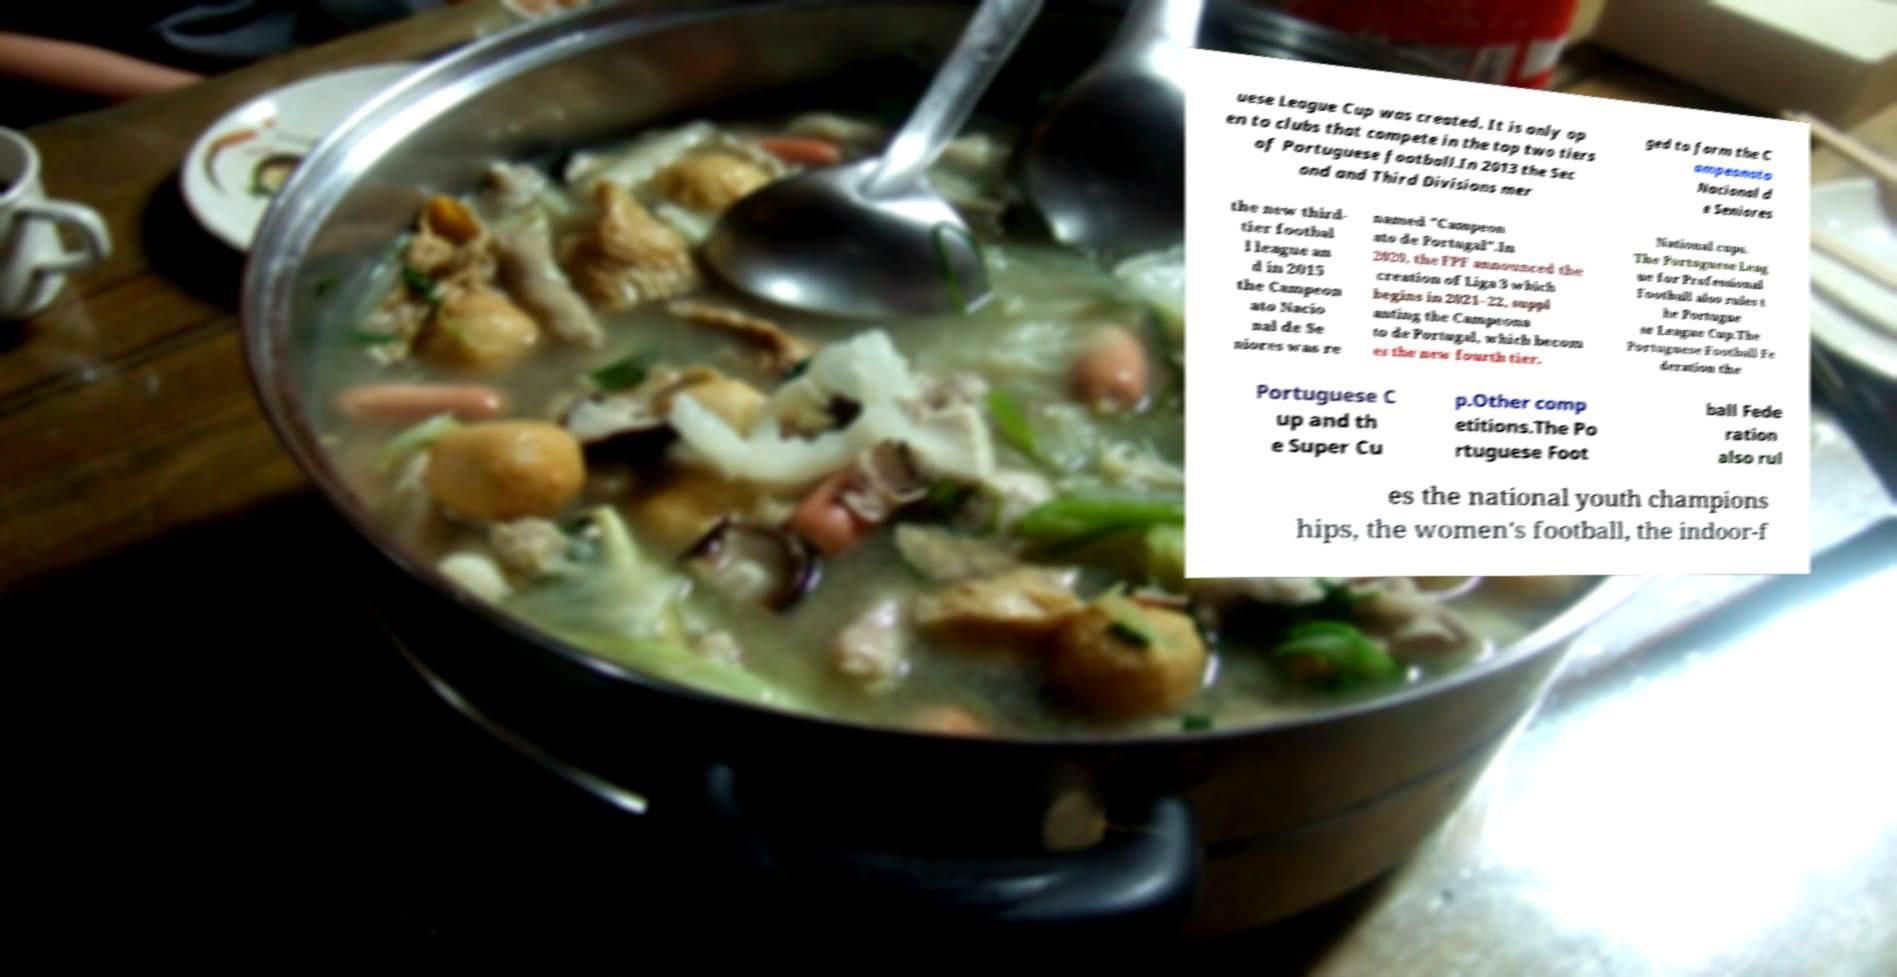There's text embedded in this image that I need extracted. Can you transcribe it verbatim? uese League Cup was created. It is only op en to clubs that compete in the top two tiers of Portuguese football.In 2013 the Sec ond and Third Divisions mer ged to form the C ampeonato Nacional d e Seniores the new third- tier footbal l league an d in 2015 the Campeon ato Nacio nal de Se niores was re named "Campeon ato de Portugal".In 2020, the FPF announced the creation of Liga 3 which begins in 2021–22, suppl anting the Campeona to de Portugal, which becom es the new fourth tier. National cups. The Portuguese Leag ue for Professional Football also rules t he Portugue se League Cup.The Portuguese Football Fe deration the Portuguese C up and th e Super Cu p.Other comp etitions.The Po rtuguese Foot ball Fede ration also rul es the national youth champions hips, the women's football, the indoor-f 